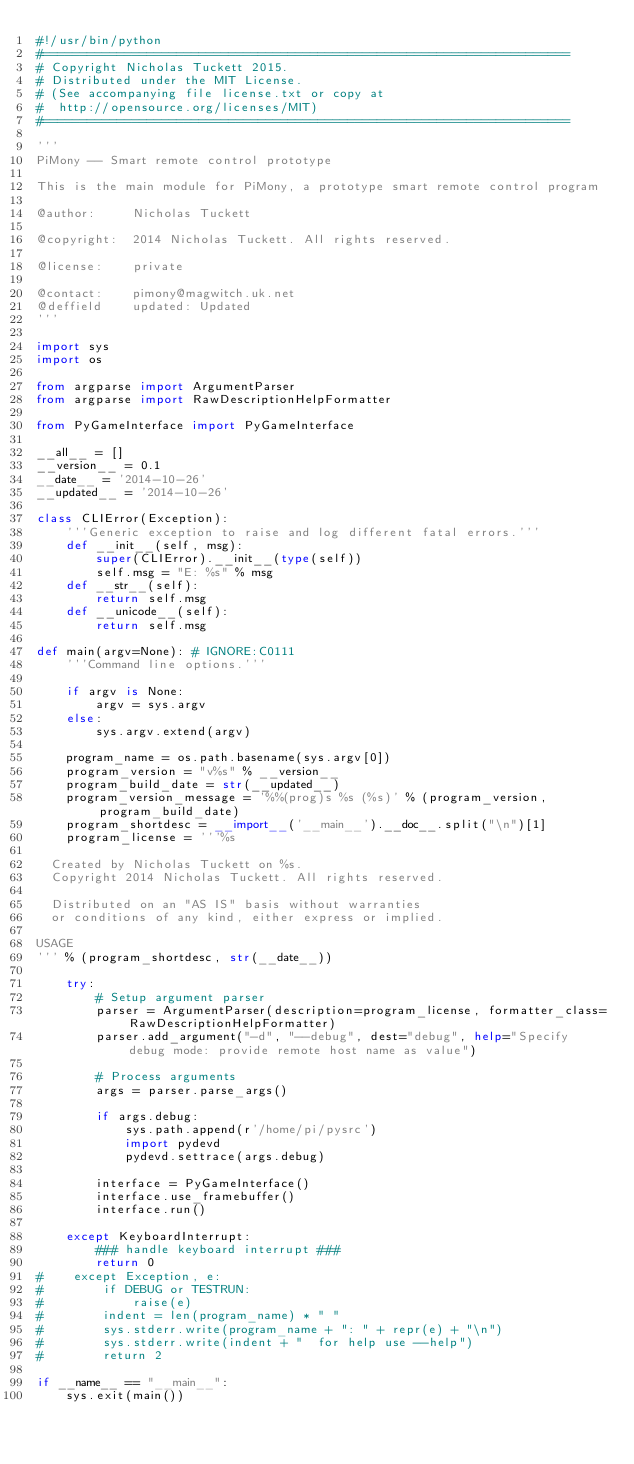<code> <loc_0><loc_0><loc_500><loc_500><_Python_>#!/usr/bin/python
#=======================================================================
# Copyright Nicholas Tuckett 2015.
# Distributed under the MIT License.
# (See accompanying file license.txt or copy at
#  http://opensource.org/licenses/MIT)
#=======================================================================

'''
PiMony -- Smart remote control prototype

This is the main module for PiMony, a prototype smart remote control program

@author:     Nicholas Tuckett

@copyright:  2014 Nicholas Tuckett. All rights reserved.

@license:    private

@contact:    pimony@magwitch.uk.net
@deffield    updated: Updated
'''

import sys
import os

from argparse import ArgumentParser
from argparse import RawDescriptionHelpFormatter

from PyGameInterface import PyGameInterface

__all__ = []
__version__ = 0.1
__date__ = '2014-10-26'
__updated__ = '2014-10-26'

class CLIError(Exception):
    '''Generic exception to raise and log different fatal errors.'''
    def __init__(self, msg):
        super(CLIError).__init__(type(self))
        self.msg = "E: %s" % msg
    def __str__(self):
        return self.msg
    def __unicode__(self):
        return self.msg

def main(argv=None): # IGNORE:C0111
    '''Command line options.'''

    if argv is None:
        argv = sys.argv
    else:
        sys.argv.extend(argv)

    program_name = os.path.basename(sys.argv[0])
    program_version = "v%s" % __version__
    program_build_date = str(__updated__)
    program_version_message = '%%(prog)s %s (%s)' % (program_version, program_build_date)
    program_shortdesc = __import__('__main__').__doc__.split("\n")[1]
    program_license = '''%s

  Created by Nicholas Tuckett on %s.
  Copyright 2014 Nicholas Tuckett. All rights reserved.

  Distributed on an "AS IS" basis without warranties
  or conditions of any kind, either express or implied.

USAGE
''' % (program_shortdesc, str(__date__))

    try:
        # Setup argument parser
        parser = ArgumentParser(description=program_license, formatter_class=RawDescriptionHelpFormatter)
        parser.add_argument("-d", "--debug", dest="debug", help="Specify debug mode: provide remote host name as value")

        # Process arguments
        args = parser.parse_args()
        
        if args.debug:
            sys.path.append(r'/home/pi/pysrc')
            import pydevd
            pydevd.settrace(args.debug)
            
        interface = PyGameInterface()
        interface.use_framebuffer()
        interface.run()
        
    except KeyboardInterrupt:
        ### handle keyboard interrupt ###
        return 0
#    except Exception, e:
#        if DEBUG or TESTRUN:
#            raise(e)
#        indent = len(program_name) * " "
#        sys.stderr.write(program_name + ": " + repr(e) + "\n")
#        sys.stderr.write(indent + "  for help use --help")
#        return 2

if __name__ == "__main__":
    sys.exit(main())
</code> 